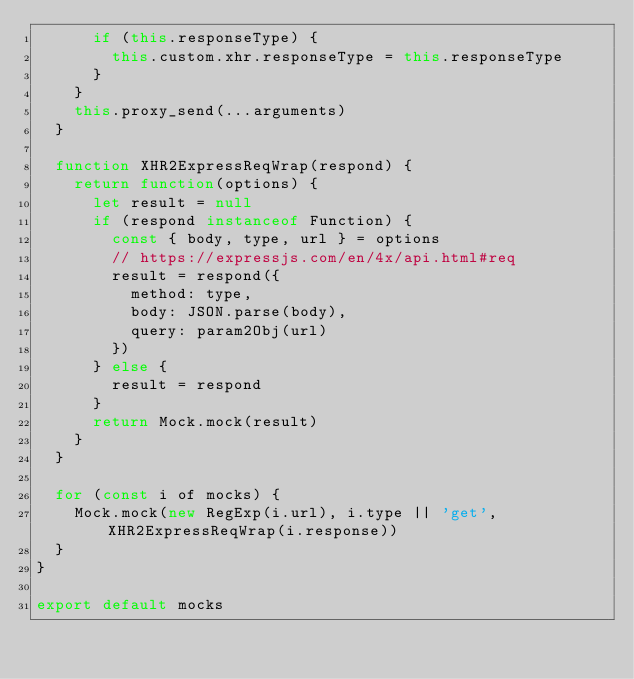Convert code to text. <code><loc_0><loc_0><loc_500><loc_500><_JavaScript_>      if (this.responseType) {
        this.custom.xhr.responseType = this.responseType
      }
    }
    this.proxy_send(...arguments)
  }

  function XHR2ExpressReqWrap(respond) {
    return function(options) {
      let result = null
      if (respond instanceof Function) {
        const { body, type, url } = options
        // https://expressjs.com/en/4x/api.html#req
        result = respond({
          method: type,
          body: JSON.parse(body),
          query: param2Obj(url)
        })
      } else {
        result = respond
      }
      return Mock.mock(result)
    }
  }

  for (const i of mocks) {
    Mock.mock(new RegExp(i.url), i.type || 'get', XHR2ExpressReqWrap(i.response))
  }
}

export default mocks
</code> 